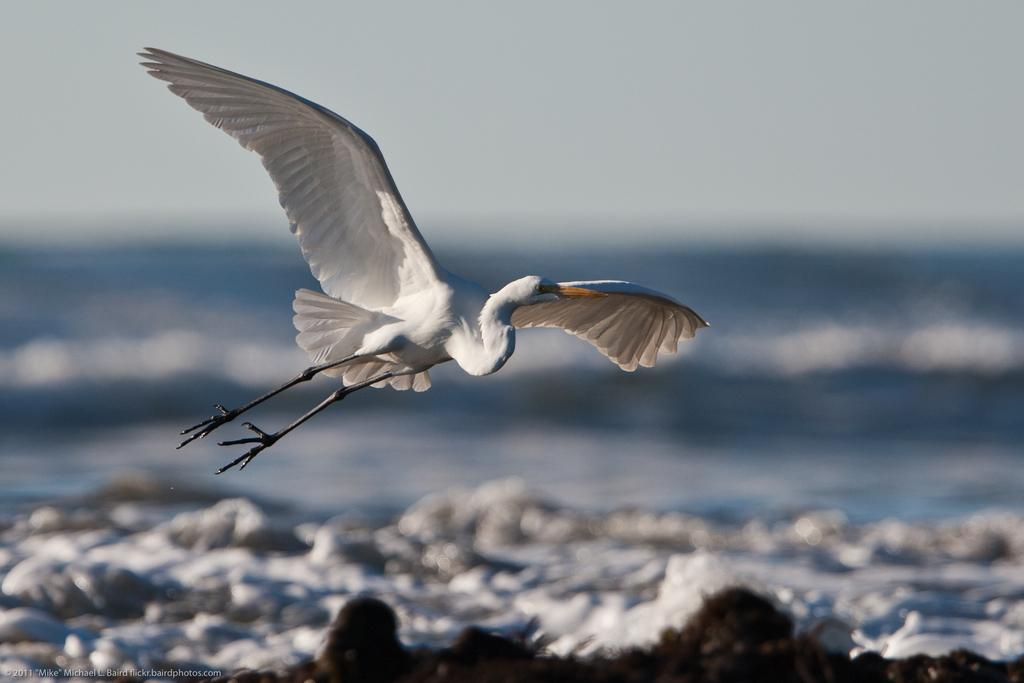What is the main subject of the image? There is a bird flying in the image. What can be seen in the background of the image? There is water visible in the image. What is at the bottom of the image? There are rocks at the bottom of the image. Is there any text present in the image? Yes, there is some text present in the image. What type of foot can be seen on the bird in the image? There is no foot visible on the bird in the image, as birds have wings and not feet for flying. 